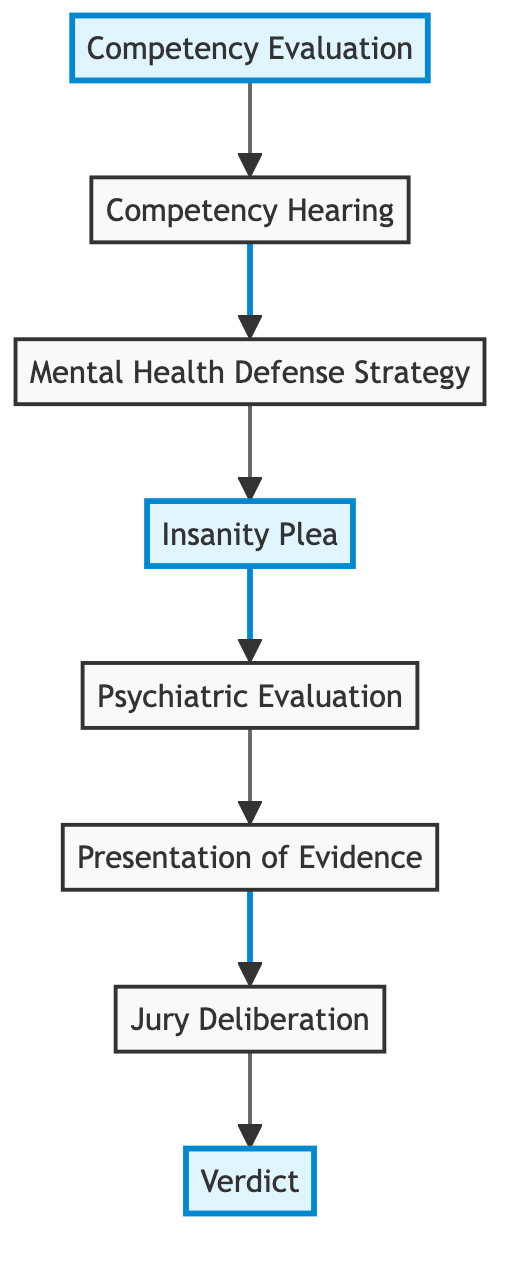What's the first element in the diagram? The first element is identified by its position at the bottom of the diagram, where the flow starts. This is "Competency Evaluation".
Answer: Competency Evaluation How many elements are in the diagram? By counting each unique element represented in the diagram, we find there are eight distinct elements listed from bottom to top.
Answer: 8 What follows the Insanity Plea in the diagram? The arrangement of elements is sequential, with "Psychiatric Evaluation" positioned immediately after "Insanity Plea", indicating the next step in the flow.
Answer: Psychiatric Evaluation Which element is directly above the Presentation of Evidence? By following the arrows indicating upward direction, "Jury Deliberation" is immediately positioned above "Presentation of Evidence".
Answer: Jury Deliberation What is the last element in the diagram? The last element is at the top of the chart, signifying the final outcome of the processes outlined, which is "Verdict".
Answer: Verdict Explain the pathway from Competency Evaluation to Insanity Plea. Starting from "Competency Evaluation," the process flows to "Competency Hearing," which then leads to the formulation of a "Mental Health Defense Strategy," where the "Insanity Plea" is formalized as part of that strategy.
Answer: Competency Evaluation → Competency Hearing → Mental Health Defense Strategy → Insanity Plea What types of outcomes are possible in the Verdict element? The Verdict element specifies possible outcomes recognized in criminal trials, which are explicitly stated as "Guilty," "Not Guilty," or "Not Guilty by Reason of Insanity."
Answer: Guilty, Not Guilty, Not Guilty by Reason of Insanity How does Jury Deliberation relate to Presentation of Evidence? Jury Deliberation relies on the evidence presented, specifically the psychiatric evaluations and testimonies provided during the Presentation of Evidence phase. The jury uses this information to make a decision.
Answer: Jury Deliberation depends on Presentation of Evidence What is the main purpose of the Competency Hearing? The primary purpose of the Competency Hearing is to assess the results of the Competency Evaluation and determine if the defendant is competent to stand trial, as decided by the judge.
Answer: Assess competency to stand trial 